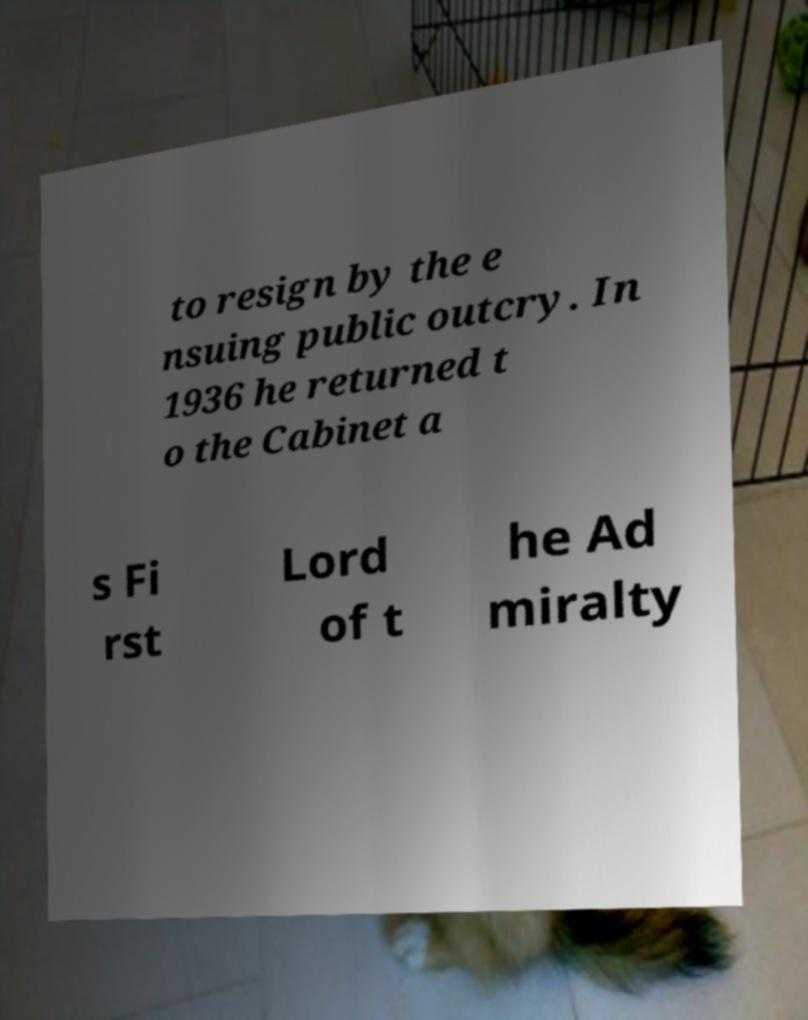Please identify and transcribe the text found in this image. to resign by the e nsuing public outcry. In 1936 he returned t o the Cabinet a s Fi rst Lord of t he Ad miralty 